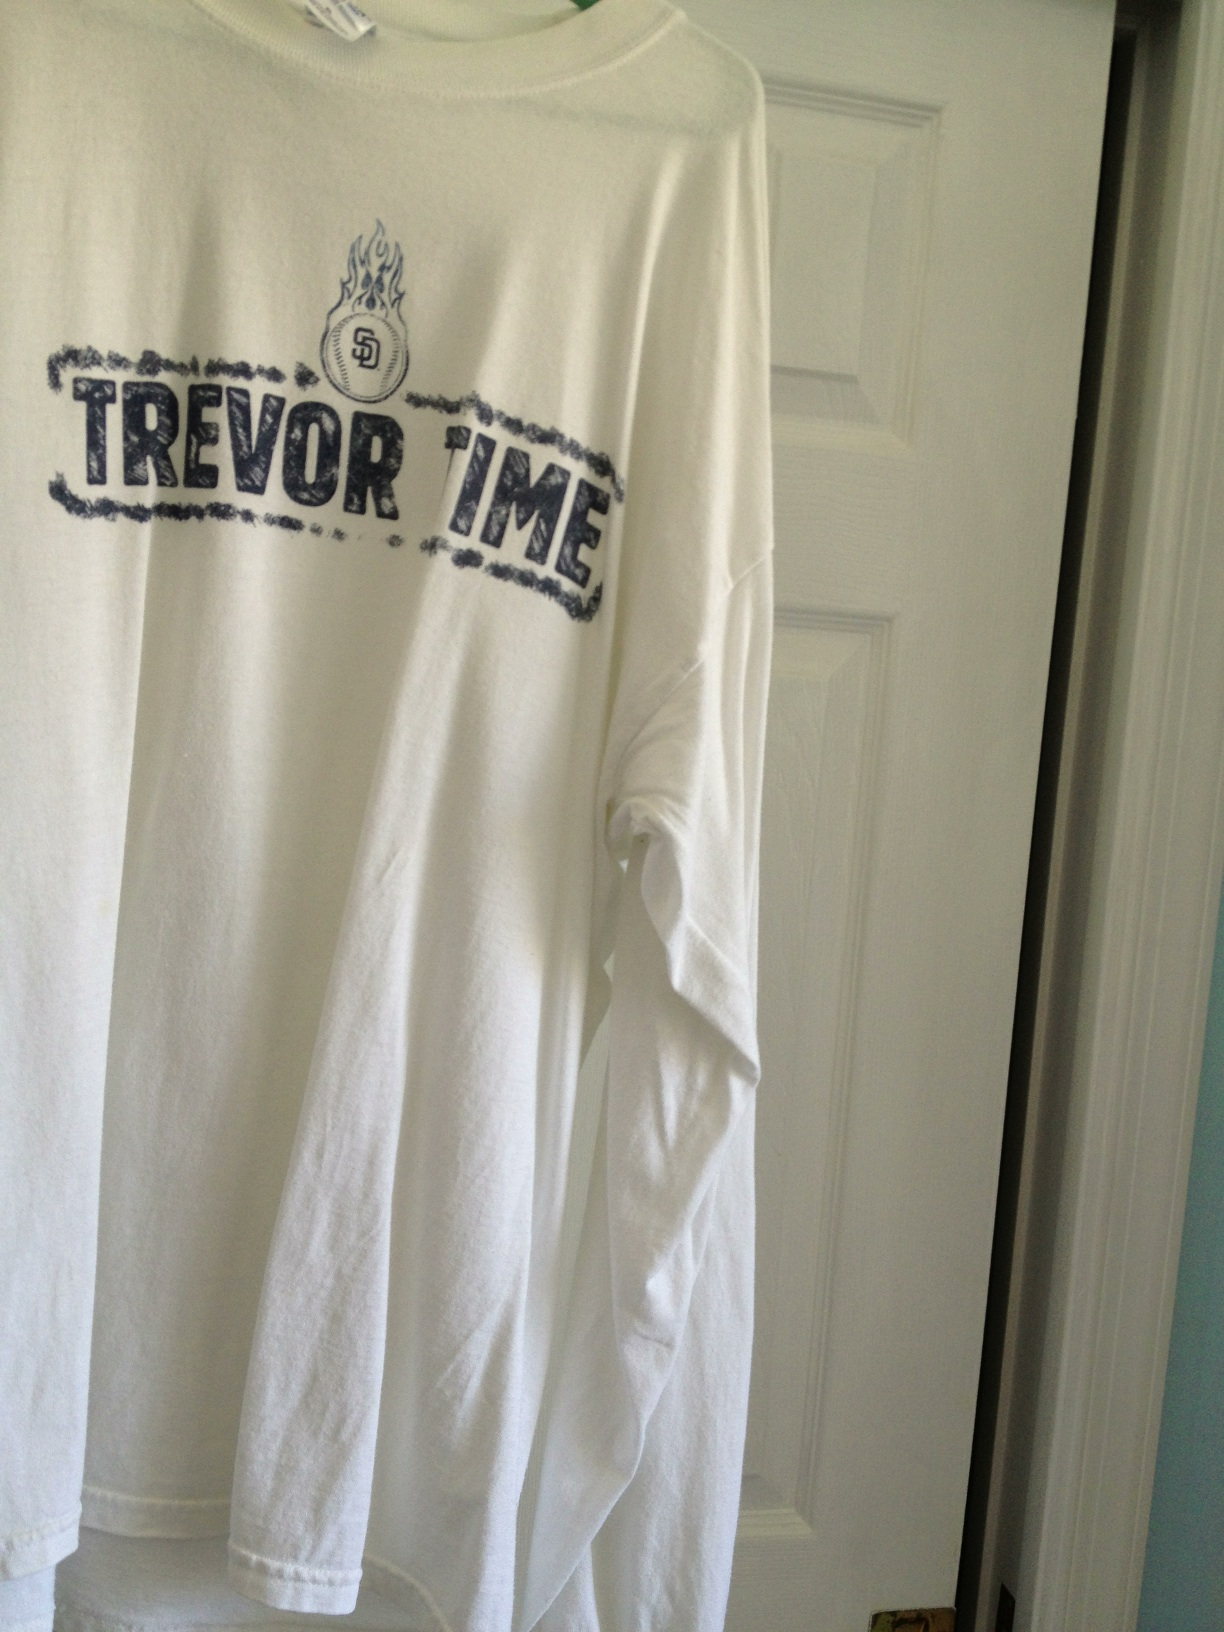Can you create a story around this shirt? This shirt once belonged to a devoted San Diego Padres fan. Every time Trevor, a star player for the Padres, took the mound, fans donned their 'TREVOЯ TIME' shirts and cheered from the stands with undying enthusiasm. The shirt became a symbol of hope and unity, worn proudly to support Trevor through every match. 